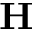<formula> <loc_0><loc_0><loc_500><loc_500>{ H }</formula> 